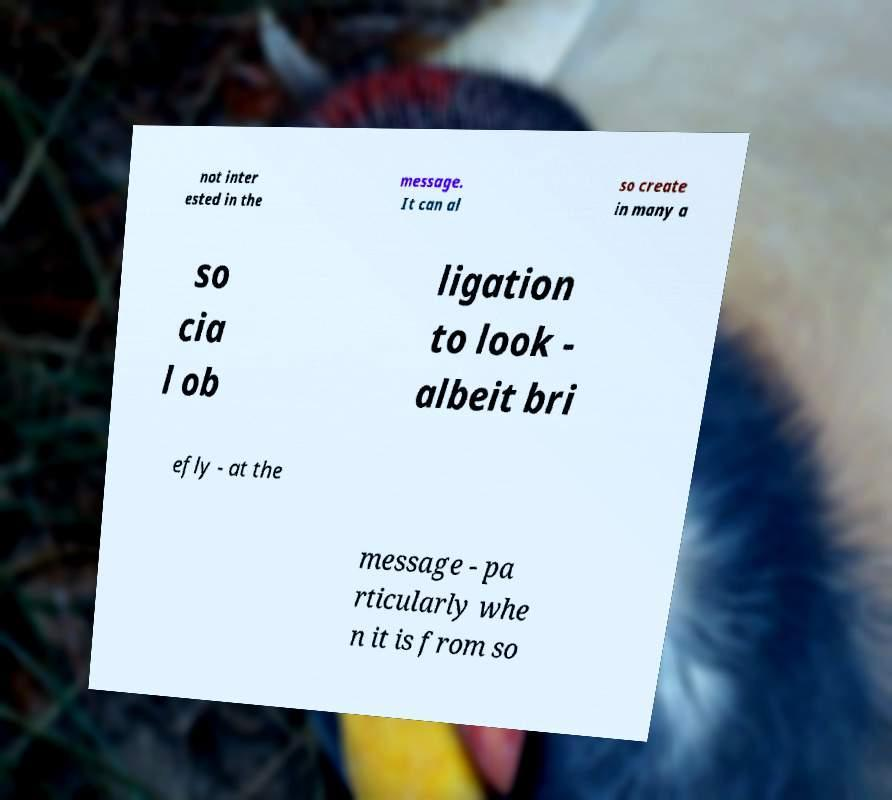What messages or text are displayed in this image? I need them in a readable, typed format. not inter ested in the message. It can al so create in many a so cia l ob ligation to look - albeit bri efly - at the message - pa rticularly whe n it is from so 